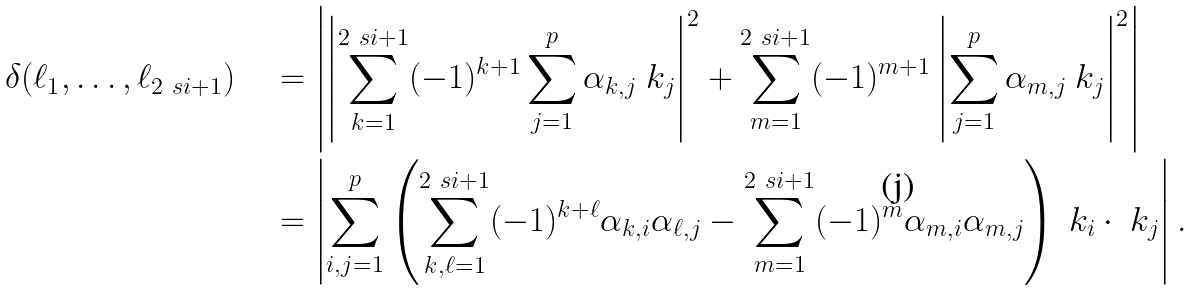<formula> <loc_0><loc_0><loc_500><loc_500>\delta ( \ell _ { 1 } , \dots , \ell _ { 2 \ s i + 1 } ) & \quad = \left | \left | \sum _ { k = 1 } ^ { 2 \ s i + 1 } ( - 1 ) ^ { k + 1 } \sum _ { j = 1 } ^ { p } \alpha _ { k , j } \ k _ { j } \right | ^ { 2 } + \sum _ { m = 1 } ^ { 2 \ s i + 1 } ( - 1 ) ^ { m + 1 } \left | \sum _ { j = 1 } ^ { p } \alpha _ { m , j } \ k _ { j } \right | ^ { 2 } \right | \\ & \quad = \left | \sum _ { i , j = 1 } ^ { p } \left ( \sum _ { k , \ell = 1 } ^ { 2 \ s i + 1 } ( - 1 ) ^ { k + \ell } \alpha _ { k , i } \alpha _ { \ell , j } - \sum _ { m = 1 } ^ { 2 \ s i + 1 } ( - 1 ) ^ { m } \alpha _ { m , i } \alpha _ { m , j } \right ) \ k _ { i } \cdot \ k _ { j } \right | .</formula> 